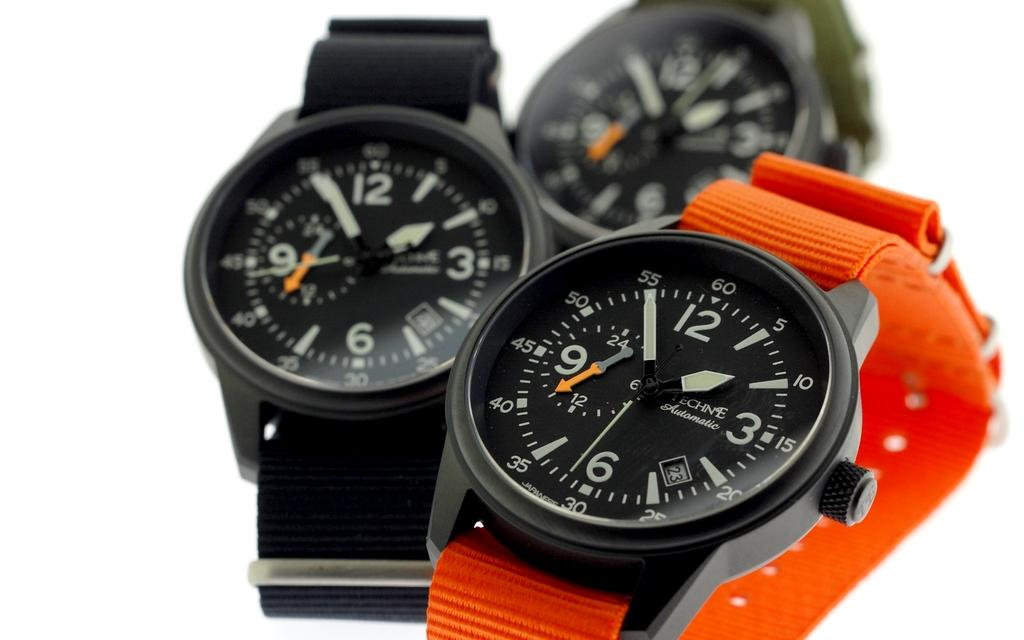Provide a one-sentence caption for the provided image. A watch with an orange band says on the face that it is an automatic watch. 